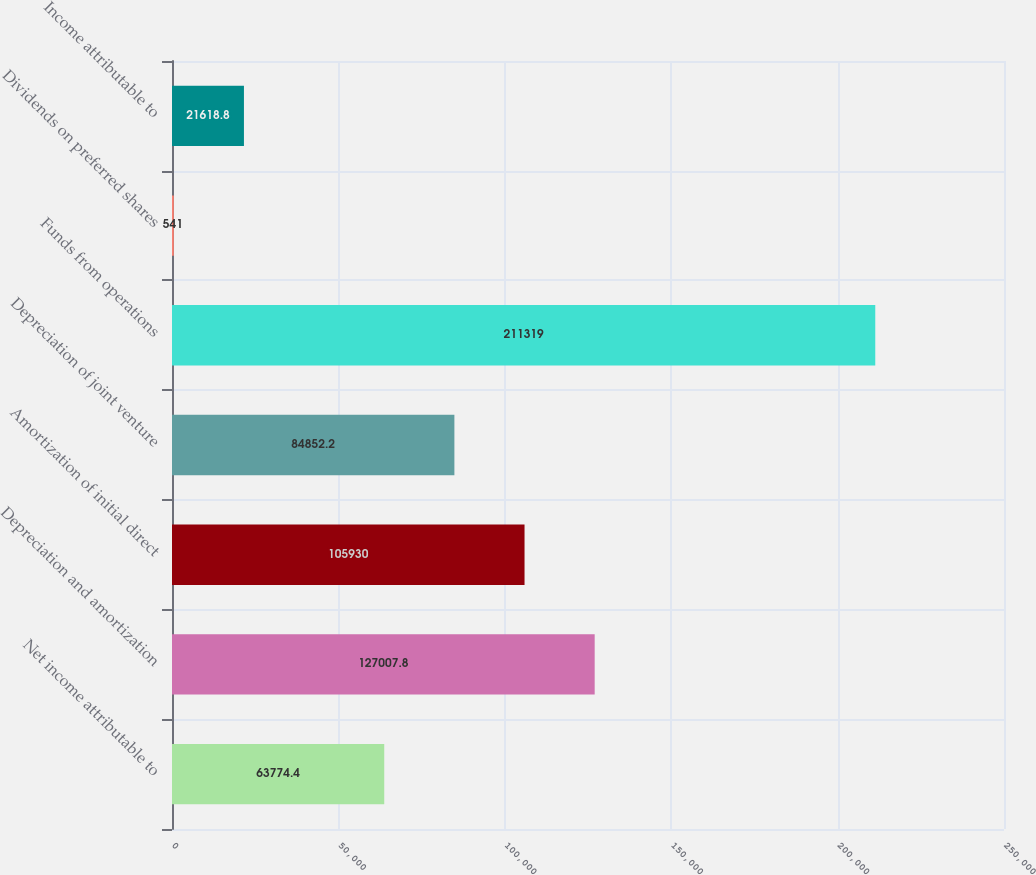Convert chart to OTSL. <chart><loc_0><loc_0><loc_500><loc_500><bar_chart><fcel>Net income attributable to<fcel>Depreciation and amortization<fcel>Amortization of initial direct<fcel>Depreciation of joint venture<fcel>Funds from operations<fcel>Dividends on preferred shares<fcel>Income attributable to<nl><fcel>63774.4<fcel>127008<fcel>105930<fcel>84852.2<fcel>211319<fcel>541<fcel>21618.8<nl></chart> 